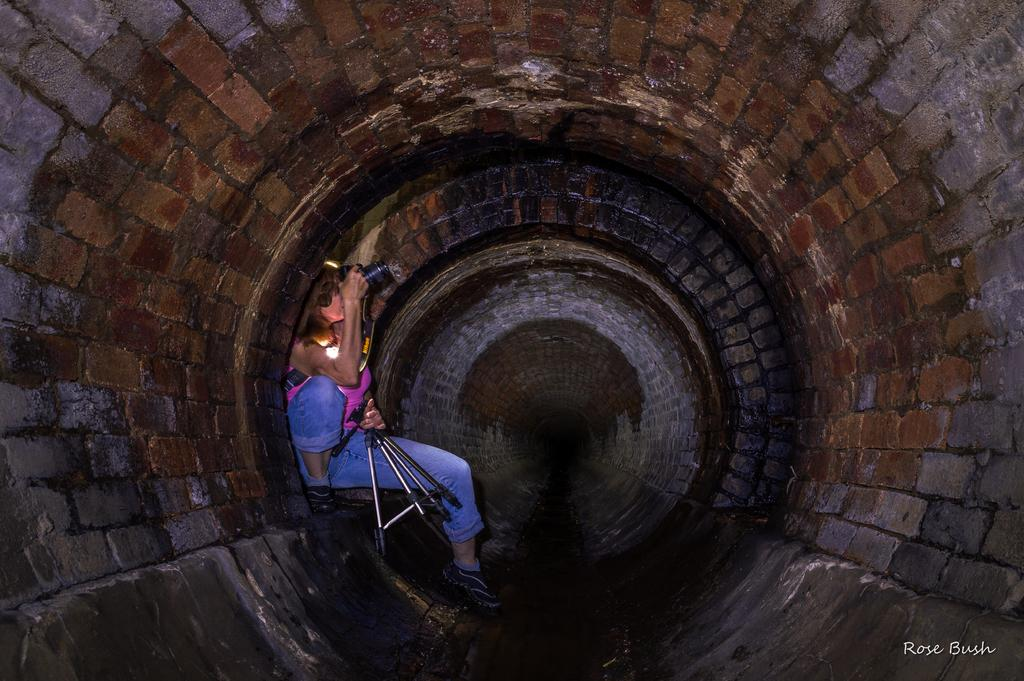Who is present in the image? There is a person in the image. What is the person holding? The person is holding a camera. What additional equipment can be seen in the image? There is a tripod stand in the image. Where does the scene take place? The scene takes place in a drainage tunnel. Is there any text or logo visible on the image? Yes, the image has a watermark. Can you see a boy playing with a plant in the image? No, there is no boy or plant present in the image. What type of rake is being used to clean the drainage tunnel in the image? There is no rake visible in the image; the person is holding a camera and standing near a tripod stand. 